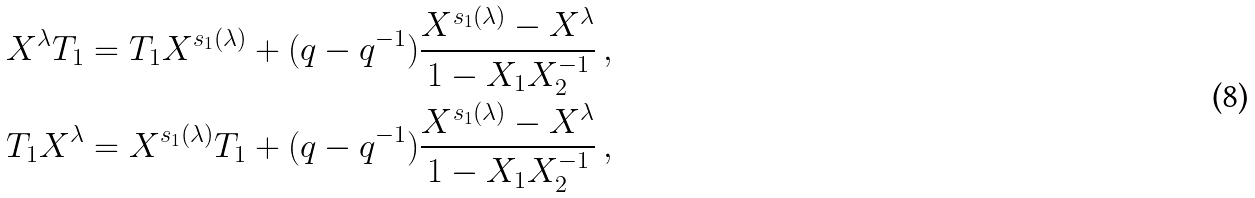Convert formula to latex. <formula><loc_0><loc_0><loc_500><loc_500>X ^ { \lambda } T _ { 1 } & = T _ { 1 } X ^ { s _ { 1 } ( \lambda ) } + ( q - q ^ { - 1 } ) \frac { X ^ { s _ { 1 } ( \lambda ) } - X ^ { \lambda } } { 1 - X _ { 1 } X _ { 2 } ^ { - 1 } } \, , \\ T _ { 1 } X ^ { \lambda } & = X ^ { s _ { 1 } ( \lambda ) } T _ { 1 } + ( q - q ^ { - 1 } ) \frac { X ^ { s _ { 1 } ( \lambda ) } - X ^ { \lambda } } { 1 - X _ { 1 } X _ { 2 } ^ { - 1 } } \, ,</formula> 